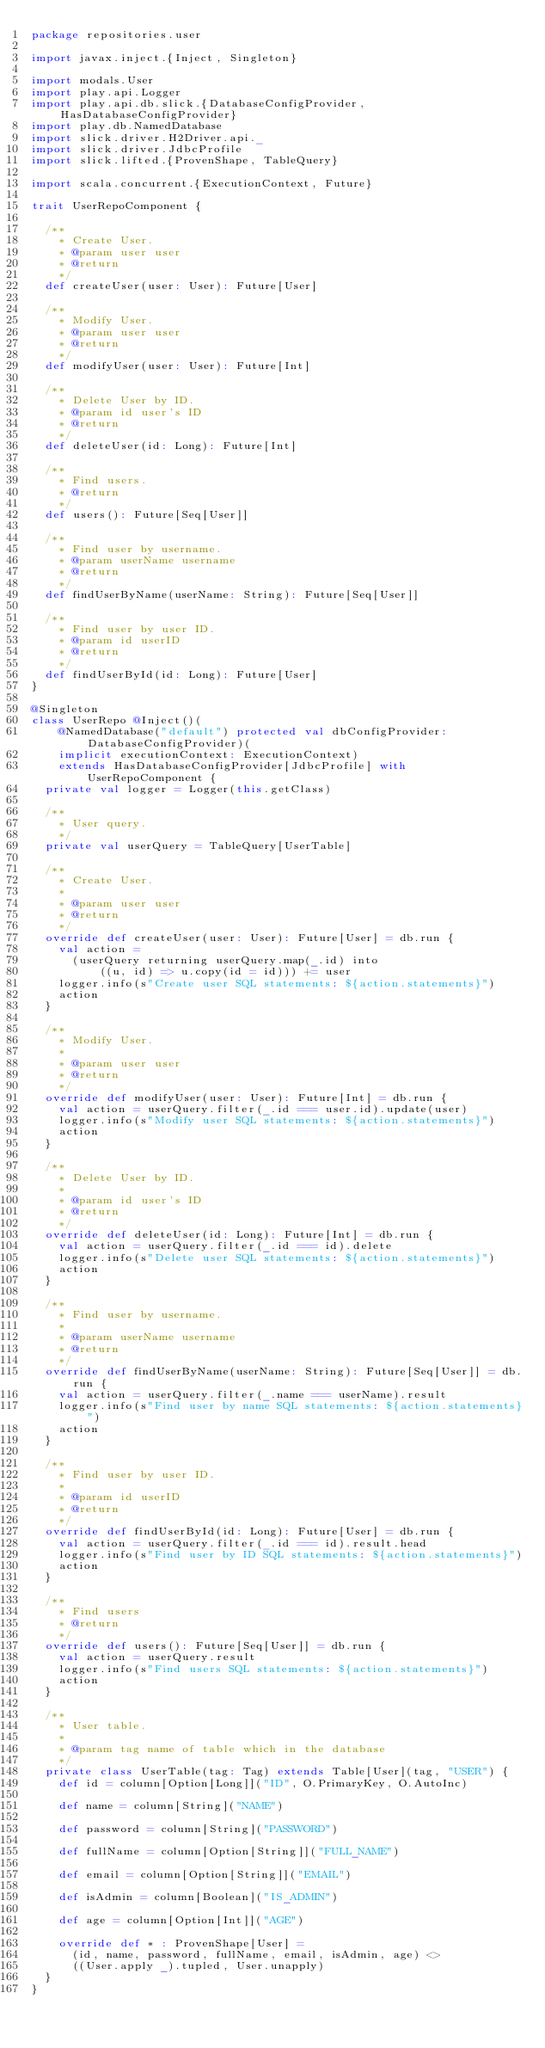<code> <loc_0><loc_0><loc_500><loc_500><_Scala_>package repositories.user

import javax.inject.{Inject, Singleton}

import modals.User
import play.api.Logger
import play.api.db.slick.{DatabaseConfigProvider, HasDatabaseConfigProvider}
import play.db.NamedDatabase
import slick.driver.H2Driver.api._
import slick.driver.JdbcProfile
import slick.lifted.{ProvenShape, TableQuery}

import scala.concurrent.{ExecutionContext, Future}

trait UserRepoComponent {

  /**
    * Create User.
    * @param user user
    * @return
    */
  def createUser(user: User): Future[User]

  /**
    * Modify User.
    * @param user user
    * @return
    */
  def modifyUser(user: User): Future[Int]

  /**
    * Delete User by ID.
    * @param id user's ID
    * @return
    */
  def deleteUser(id: Long): Future[Int]

  /**
    * Find users.
    * @return
    */
  def users(): Future[Seq[User]]

  /**
    * Find user by username.
    * @param userName username
    * @return
    */
  def findUserByName(userName: String): Future[Seq[User]]

  /**
    * Find user by user ID.
    * @param id userID
    * @return
    */
  def findUserById(id: Long): Future[User]
}

@Singleton
class UserRepo @Inject()(
    @NamedDatabase("default") protected val dbConfigProvider: DatabaseConfigProvider)(
    implicit executionContext: ExecutionContext)
    extends HasDatabaseConfigProvider[JdbcProfile] with UserRepoComponent {
  private val logger = Logger(this.getClass)

  /**
    * User query.
    */
  private val userQuery = TableQuery[UserTable]

  /**
    * Create User.
    *
    * @param user user
    * @return
    */
  override def createUser(user: User): Future[User] = db.run {
    val action =
      (userQuery returning userQuery.map(_.id) into
          ((u, id) => u.copy(id = id))) += user
    logger.info(s"Create user SQL statements: ${action.statements}")
    action
  }

  /**
    * Modify User.
    *
    * @param user user
    * @return
    */
  override def modifyUser(user: User): Future[Int] = db.run {
    val action = userQuery.filter(_.id === user.id).update(user)
    logger.info(s"Modify user SQL statements: ${action.statements}")
    action
  }

  /**
    * Delete User by ID.
    *
    * @param id user's ID
    * @return
    */
  override def deleteUser(id: Long): Future[Int] = db.run {
    val action = userQuery.filter(_.id === id).delete
    logger.info(s"Delete user SQL statements: ${action.statements}")
    action
  }

  /**
    * Find user by username.
    *
    * @param userName username
    * @return
    */
  override def findUserByName(userName: String): Future[Seq[User]] = db.run {
    val action = userQuery.filter(_.name === userName).result
    logger.info(s"Find user by name SQL statements: ${action.statements}")
    action
  }

  /**
    * Find user by user ID.
    *
    * @param id userID
    * @return
    */
  override def findUserById(id: Long): Future[User] = db.run {
    val action = userQuery.filter(_.id === id).result.head
    logger.info(s"Find user by ID SQL statements: ${action.statements}")
    action
  }

  /**
    * Find users
    * @return
    */
  override def users(): Future[Seq[User]] = db.run {
    val action = userQuery.result
    logger.info(s"Find users SQL statements: ${action.statements}")
    action
  }

  /**
    * User table.
    *
    * @param tag name of table which in the database
    */
  private class UserTable(tag: Tag) extends Table[User](tag, "USER") {
    def id = column[Option[Long]]("ID", O.PrimaryKey, O.AutoInc)

    def name = column[String]("NAME")

    def password = column[String]("PASSWORD")

    def fullName = column[Option[String]]("FULL_NAME")

    def email = column[Option[String]]("EMAIL")

    def isAdmin = column[Boolean]("IS_ADMIN")

    def age = column[Option[Int]]("AGE")

    override def * : ProvenShape[User] =
      (id, name, password, fullName, email, isAdmin, age) <>
      ((User.apply _).tupled, User.unapply)
  }
}
</code> 